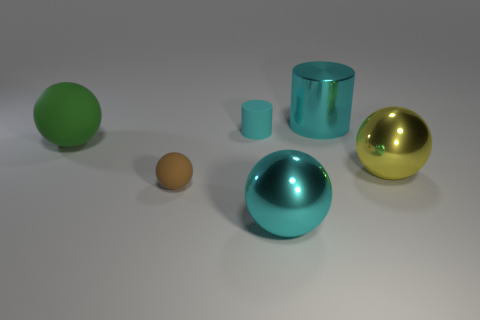There is a yellow thing that is the same size as the metal cylinder; what is it made of?
Ensure brevity in your answer.  Metal. What number of other objects are there of the same material as the brown ball?
Your answer should be very brief. 2. Do the shiny thing in front of the tiny brown thing and the shiny object behind the big yellow metallic thing have the same color?
Offer a terse response. Yes. What shape is the large thing that is to the left of the brown thing on the left side of the small cylinder?
Offer a very short reply. Sphere. What number of other things are there of the same color as the small rubber sphere?
Offer a very short reply. 0. Are the large cyan object in front of the green sphere and the large cyan thing behind the big yellow object made of the same material?
Give a very brief answer. Yes. How big is the cyan thing in front of the green rubber thing?
Provide a short and direct response. Large. There is a green object that is the same shape as the tiny brown object; what material is it?
Make the answer very short. Rubber. There is a large cyan shiny thing that is in front of the small matte sphere; what shape is it?
Keep it short and to the point. Sphere. What number of other shiny objects have the same shape as the big yellow thing?
Keep it short and to the point. 1. 